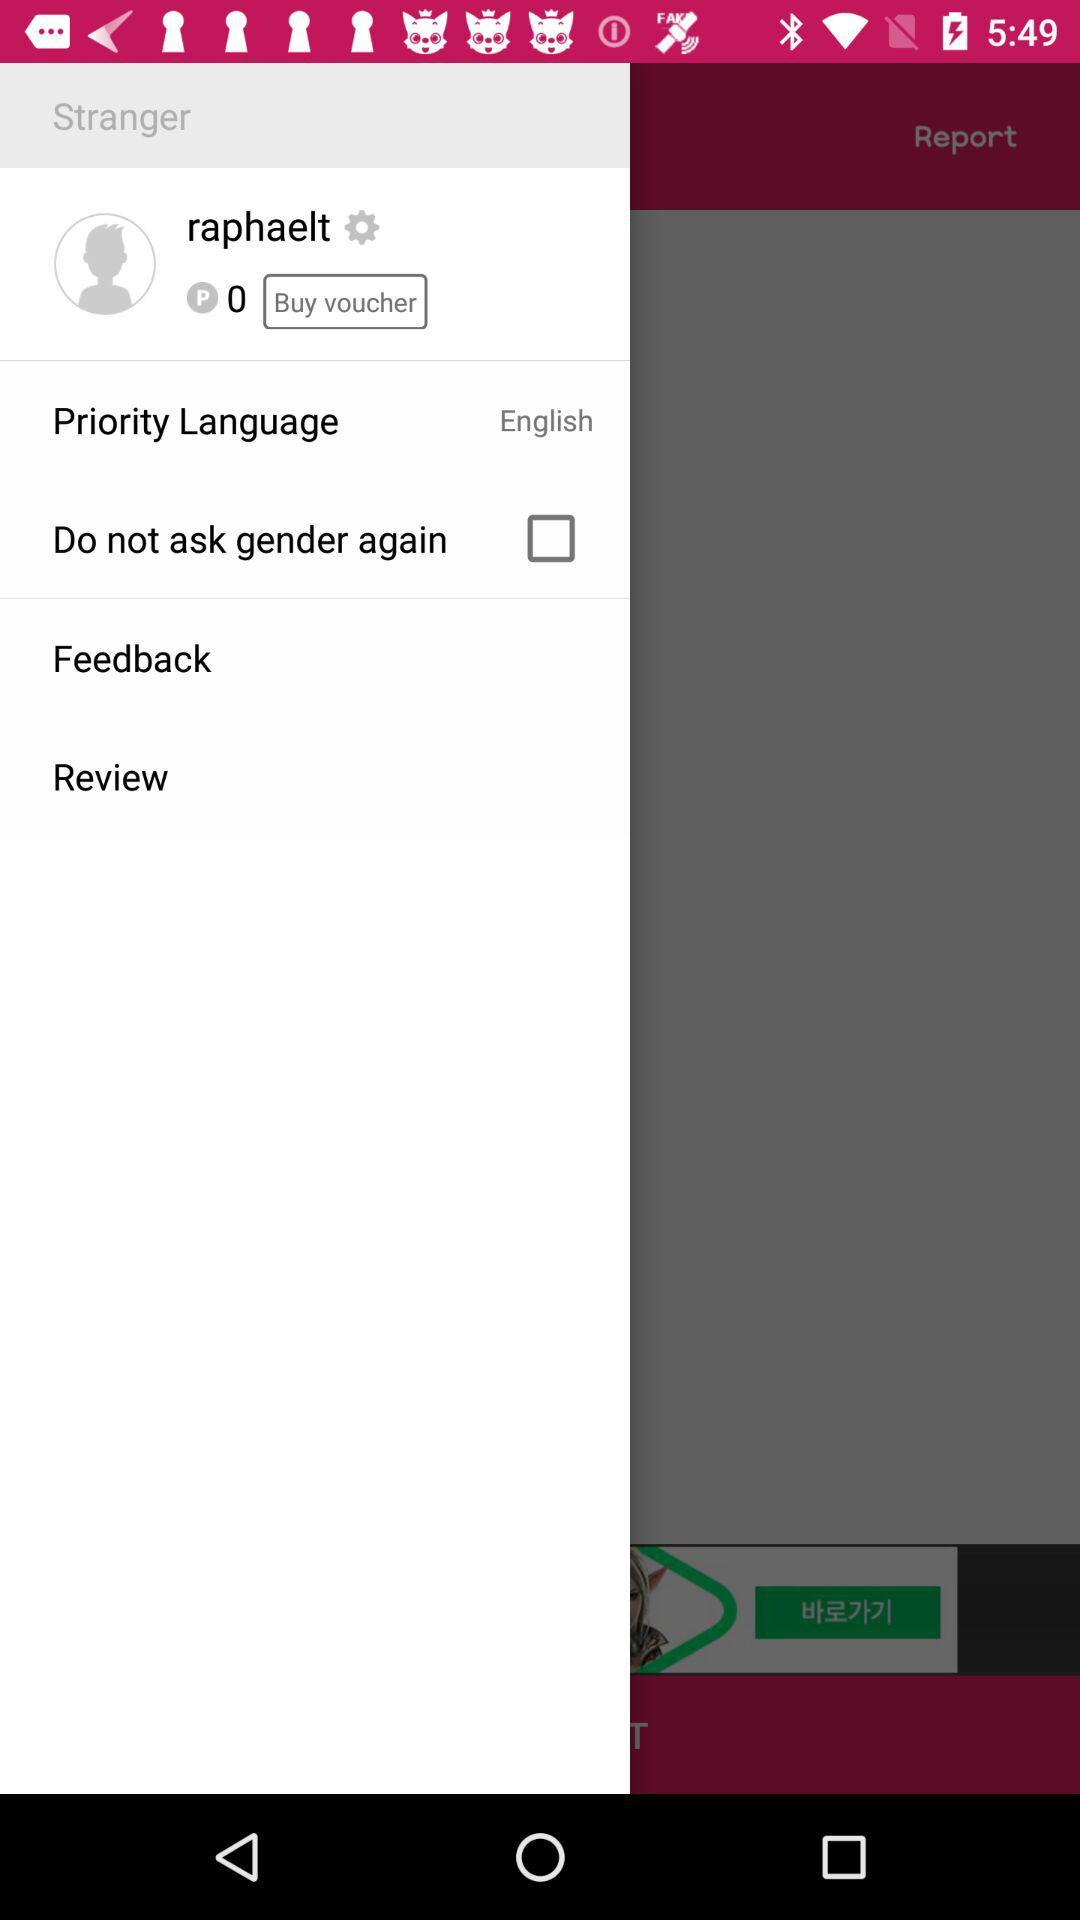What is the name of the user? The name of the user is Raphaelt. 